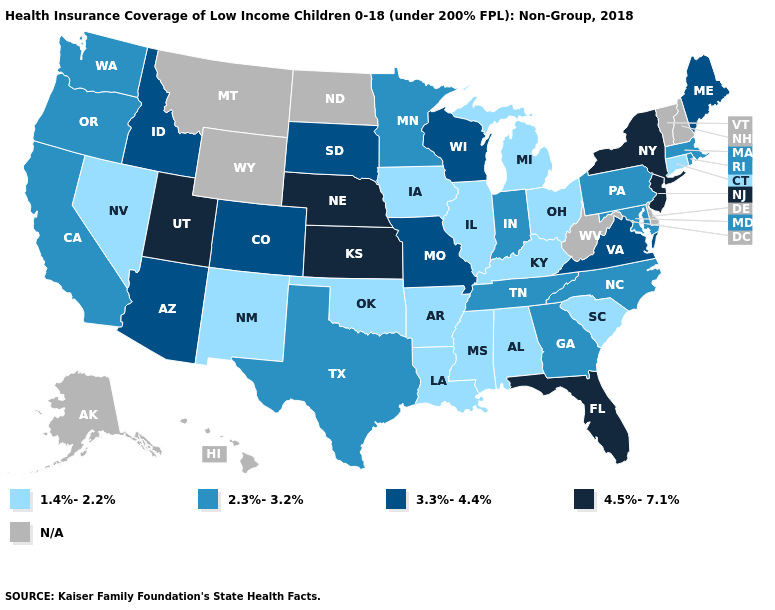Does the map have missing data?
Give a very brief answer. Yes. What is the lowest value in states that border South Carolina?
Answer briefly. 2.3%-3.2%. Which states have the lowest value in the USA?
Concise answer only. Alabama, Arkansas, Connecticut, Illinois, Iowa, Kentucky, Louisiana, Michigan, Mississippi, Nevada, New Mexico, Ohio, Oklahoma, South Carolina. Among the states that border Kansas , which have the highest value?
Be succinct. Nebraska. Which states have the lowest value in the USA?
Short answer required. Alabama, Arkansas, Connecticut, Illinois, Iowa, Kentucky, Louisiana, Michigan, Mississippi, Nevada, New Mexico, Ohio, Oklahoma, South Carolina. Name the states that have a value in the range 3.3%-4.4%?
Give a very brief answer. Arizona, Colorado, Idaho, Maine, Missouri, South Dakota, Virginia, Wisconsin. Name the states that have a value in the range 3.3%-4.4%?
Write a very short answer. Arizona, Colorado, Idaho, Maine, Missouri, South Dakota, Virginia, Wisconsin. Does New York have the lowest value in the USA?
Give a very brief answer. No. Name the states that have a value in the range 4.5%-7.1%?
Write a very short answer. Florida, Kansas, Nebraska, New Jersey, New York, Utah. Name the states that have a value in the range N/A?
Quick response, please. Alaska, Delaware, Hawaii, Montana, New Hampshire, North Dakota, Vermont, West Virginia, Wyoming. Which states hav the highest value in the West?
Quick response, please. Utah. Name the states that have a value in the range 2.3%-3.2%?
Write a very short answer. California, Georgia, Indiana, Maryland, Massachusetts, Minnesota, North Carolina, Oregon, Pennsylvania, Rhode Island, Tennessee, Texas, Washington. Does the map have missing data?
Be succinct. Yes. What is the value of Nevada?
Write a very short answer. 1.4%-2.2%. Name the states that have a value in the range 3.3%-4.4%?
Keep it brief. Arizona, Colorado, Idaho, Maine, Missouri, South Dakota, Virginia, Wisconsin. 